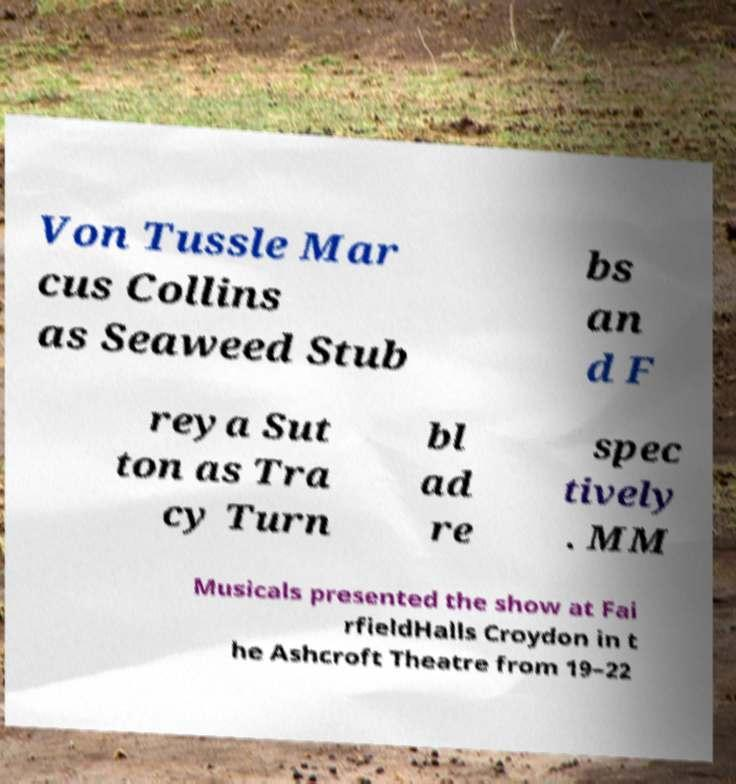Can you read and provide the text displayed in the image?This photo seems to have some interesting text. Can you extract and type it out for me? Von Tussle Mar cus Collins as Seaweed Stub bs an d F reya Sut ton as Tra cy Turn bl ad re spec tively . MM Musicals presented the show at Fai rfieldHalls Croydon in t he Ashcroft Theatre from 19–22 